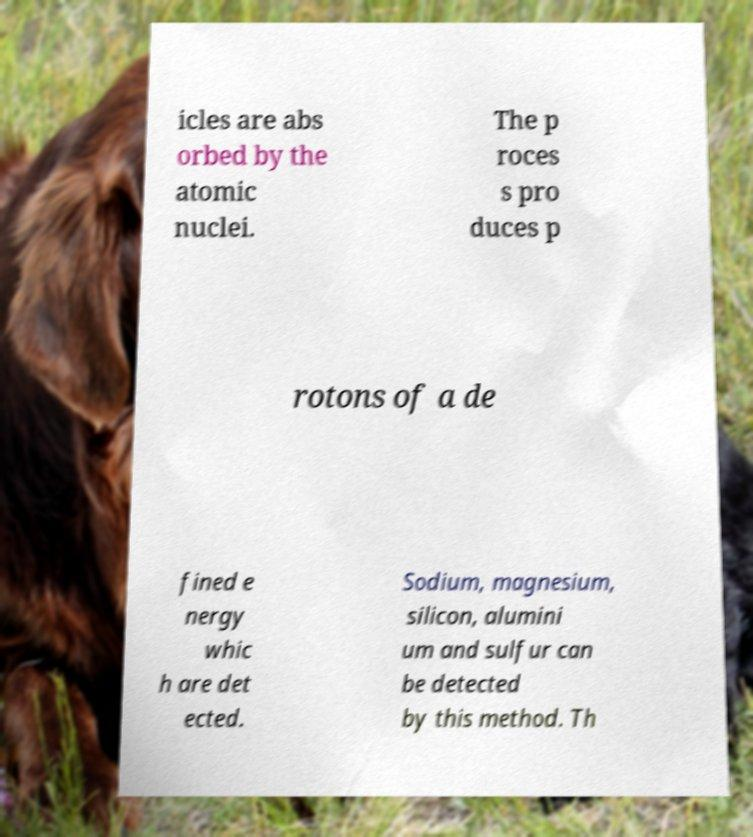For documentation purposes, I need the text within this image transcribed. Could you provide that? icles are abs orbed by the atomic nuclei. The p roces s pro duces p rotons of a de fined e nergy whic h are det ected. Sodium, magnesium, silicon, alumini um and sulfur can be detected by this method. Th 